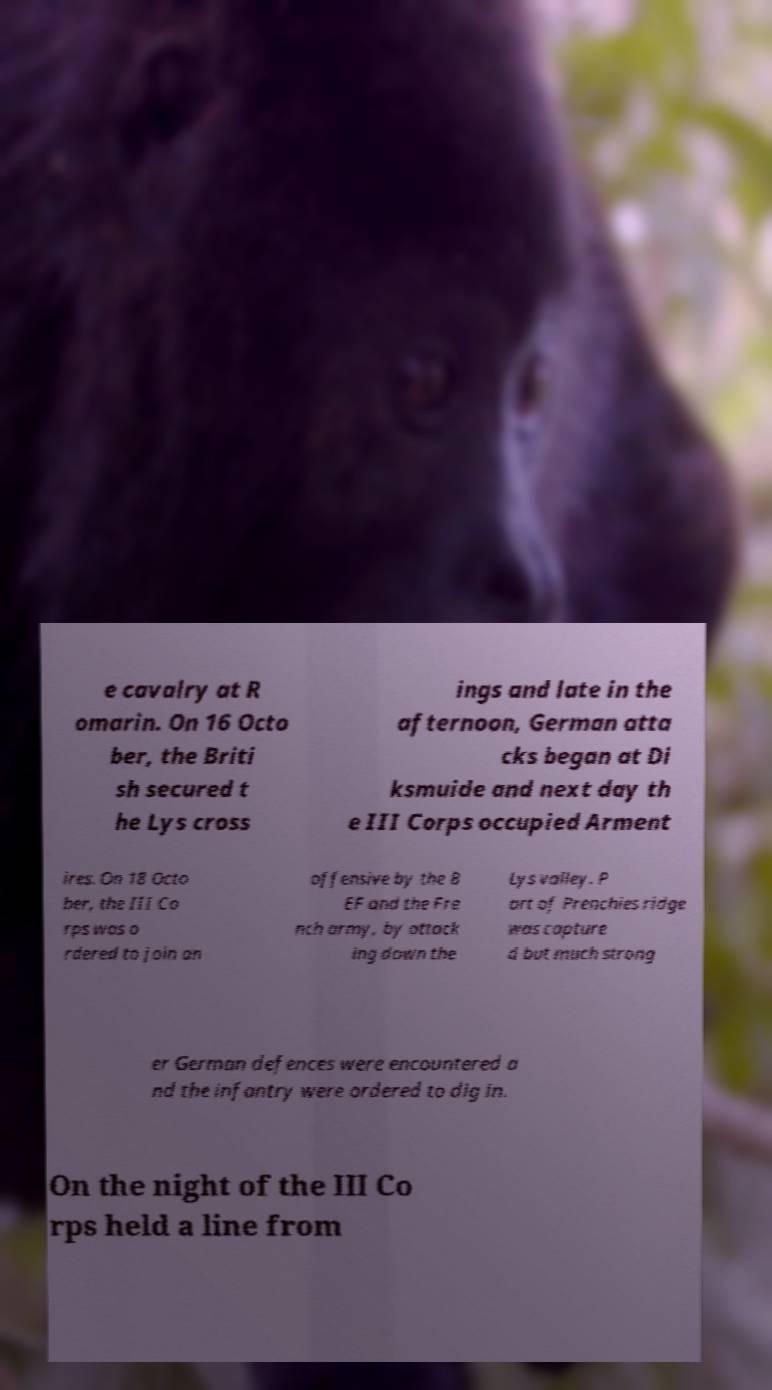There's text embedded in this image that I need extracted. Can you transcribe it verbatim? e cavalry at R omarin. On 16 Octo ber, the Briti sh secured t he Lys cross ings and late in the afternoon, German atta cks began at Di ksmuide and next day th e III Corps occupied Arment ires. On 18 Octo ber, the III Co rps was o rdered to join an offensive by the B EF and the Fre nch army, by attack ing down the Lys valley. P art of Prenchies ridge was capture d but much strong er German defences were encountered a nd the infantry were ordered to dig in. On the night of the III Co rps held a line from 